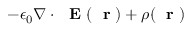Convert formula to latex. <formula><loc_0><loc_0><loc_500><loc_500>- \epsilon _ { 0 } \nabla \cdot E ( r ) + \rho ( r )</formula> 